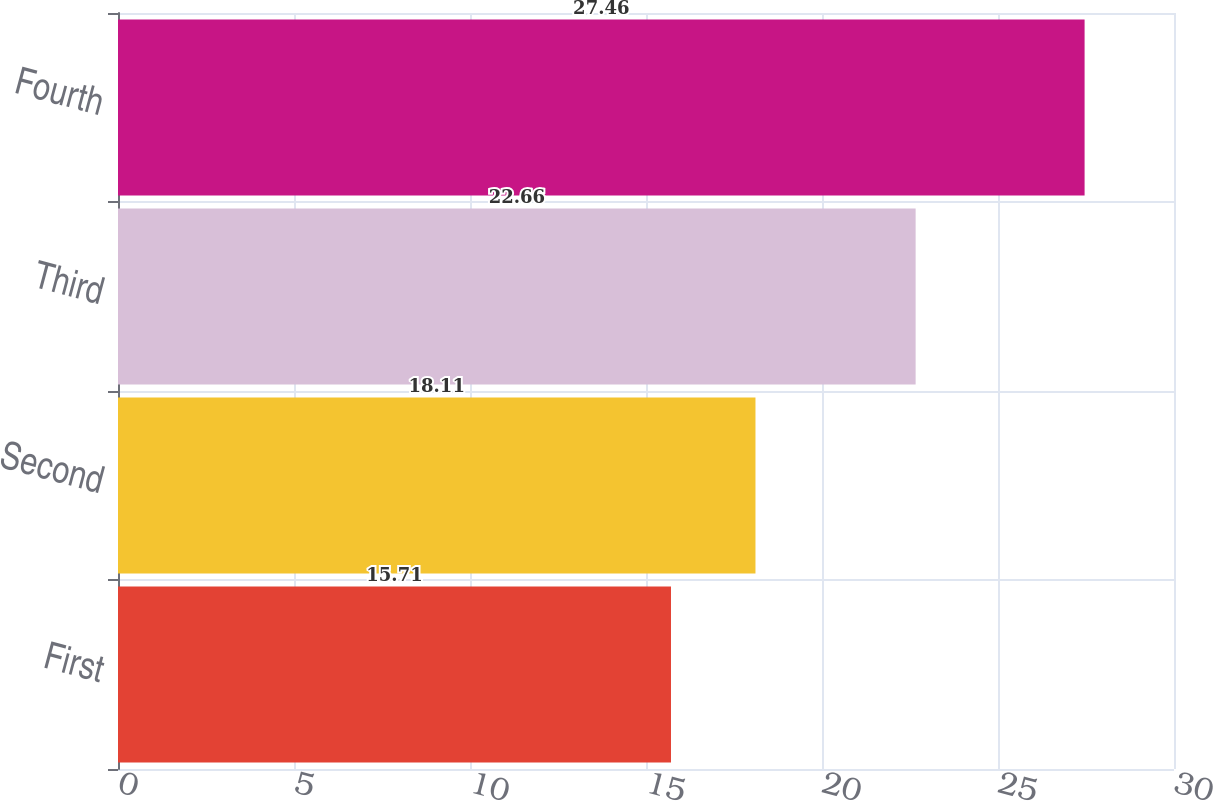Convert chart to OTSL. <chart><loc_0><loc_0><loc_500><loc_500><bar_chart><fcel>First<fcel>Second<fcel>Third<fcel>Fourth<nl><fcel>15.71<fcel>18.11<fcel>22.66<fcel>27.46<nl></chart> 